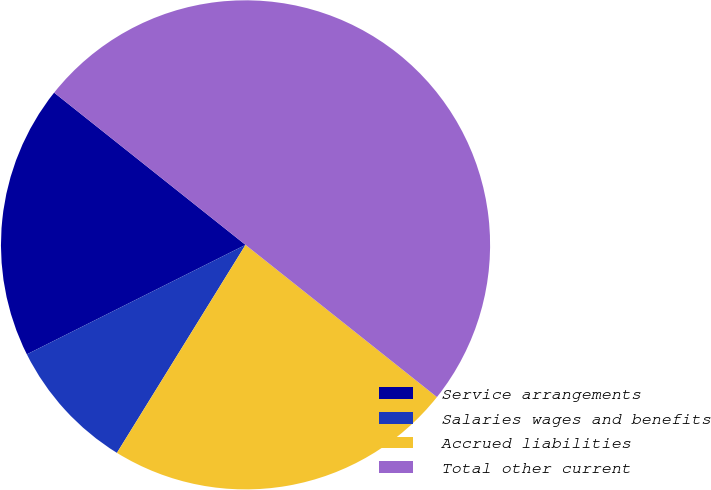Convert chart to OTSL. <chart><loc_0><loc_0><loc_500><loc_500><pie_chart><fcel>Service arrangements<fcel>Salaries wages and benefits<fcel>Accrued liabilities<fcel>Total other current<nl><fcel>18.08%<fcel>8.8%<fcel>23.12%<fcel>50.0%<nl></chart> 